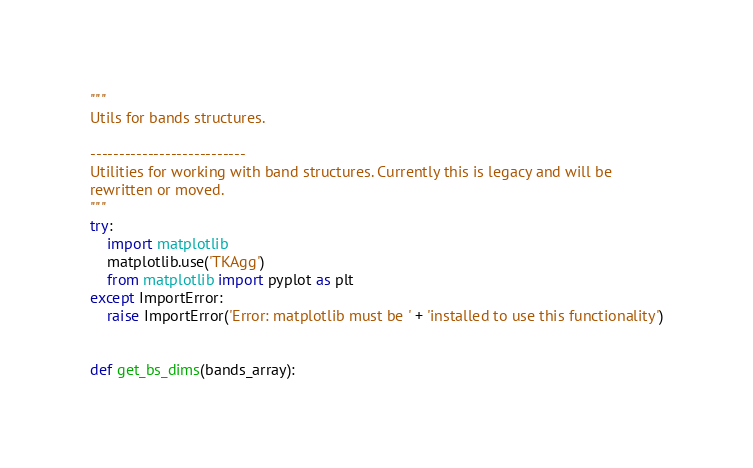<code> <loc_0><loc_0><loc_500><loc_500><_Python_>"""
Utils for bands structures.

---------------------------
Utilities for working with band structures. Currently this is legacy and will be
rewritten or moved.
"""
try:
    import matplotlib
    matplotlib.use('TKAgg')
    from matplotlib import pyplot as plt
except ImportError:
    raise ImportError('Error: matplotlib must be ' + 'installed to use this functionality')


def get_bs_dims(bands_array):</code> 